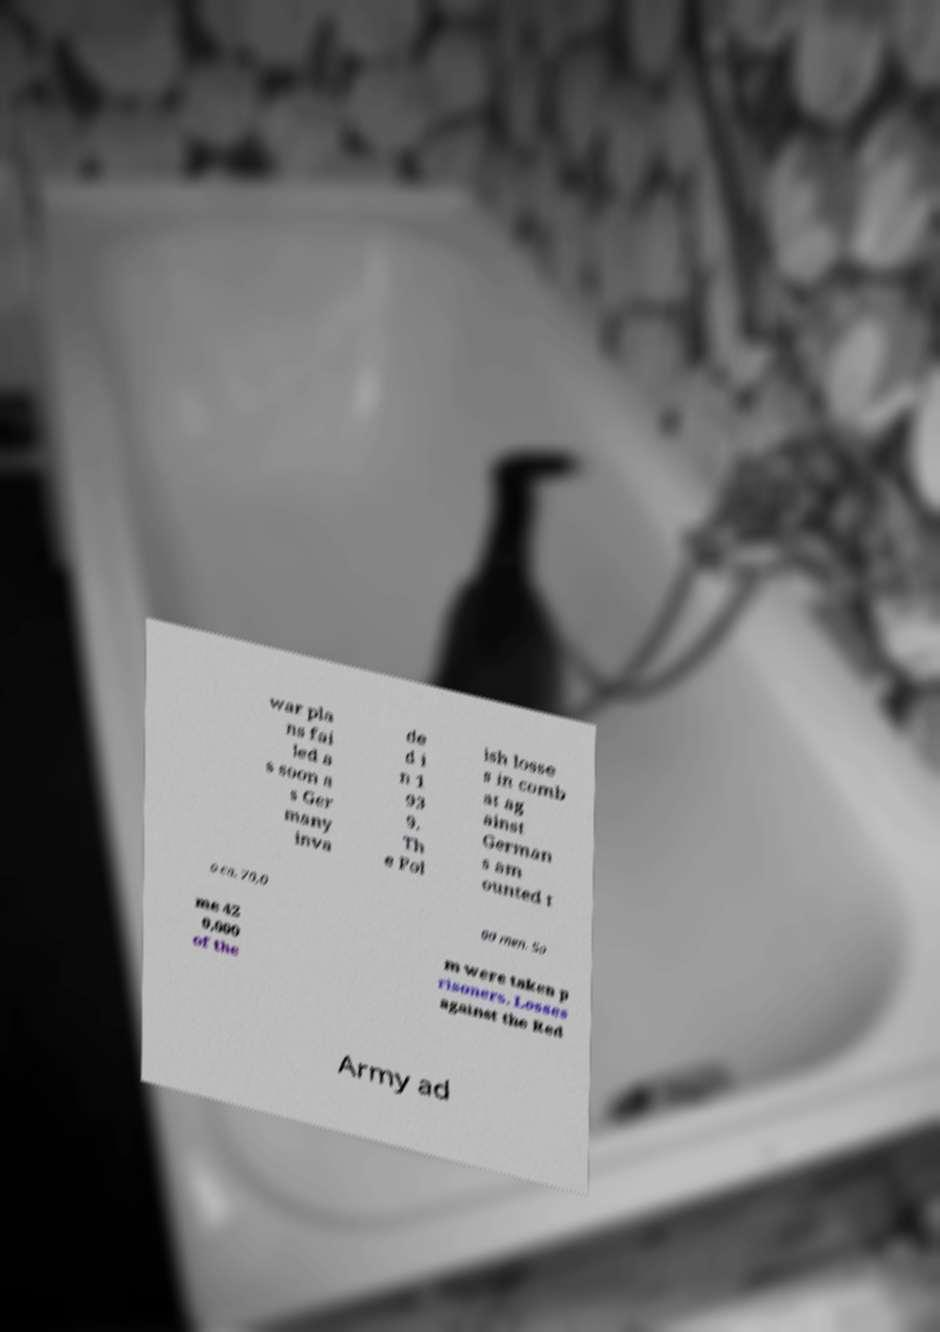Can you accurately transcribe the text from the provided image for me? war pla ns fai led a s soon a s Ger many inva de d i n 1 93 9. Th e Pol ish losse s in comb at ag ainst German s am ounted t o ca. 70,0 00 men. So me 42 0,000 of the m were taken p risoners. Losses against the Red Army ad 